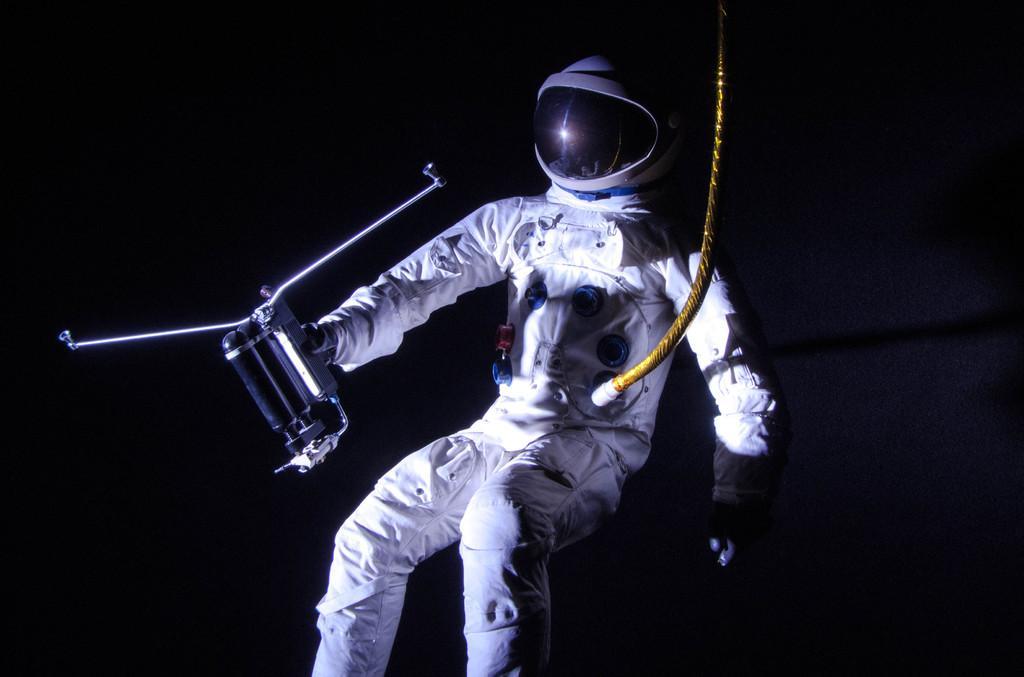Describe this image in one or two sentences. In this image there is an astronaut holding some object in his hand and there is a rope connected to his spacesuit. 